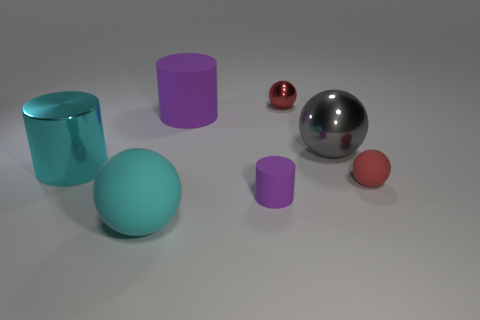What material is the small ball that is the same color as the small metallic object?
Your answer should be very brief. Rubber. The gray metal object has what shape?
Ensure brevity in your answer.  Sphere. How many tiny rubber spheres are left of the sphere in front of the tiny rubber thing that is behind the small purple thing?
Make the answer very short. 0. What number of other things are the same material as the big cyan sphere?
Your response must be concise. 3. There is a cyan cylinder that is the same size as the cyan sphere; what is its material?
Provide a succinct answer. Metal. There is a big ball that is in front of the cyan metallic thing; is it the same color as the shiny thing left of the small red shiny sphere?
Offer a very short reply. Yes. Is there a tiny cyan object that has the same shape as the big purple rubber object?
Make the answer very short. No. There is a purple thing that is the same size as the red metal object; what shape is it?
Your answer should be very brief. Cylinder. What number of metallic objects have the same color as the big rubber sphere?
Provide a succinct answer. 1. There is a matte sphere that is left of the gray shiny thing; what is its size?
Offer a very short reply. Large. 